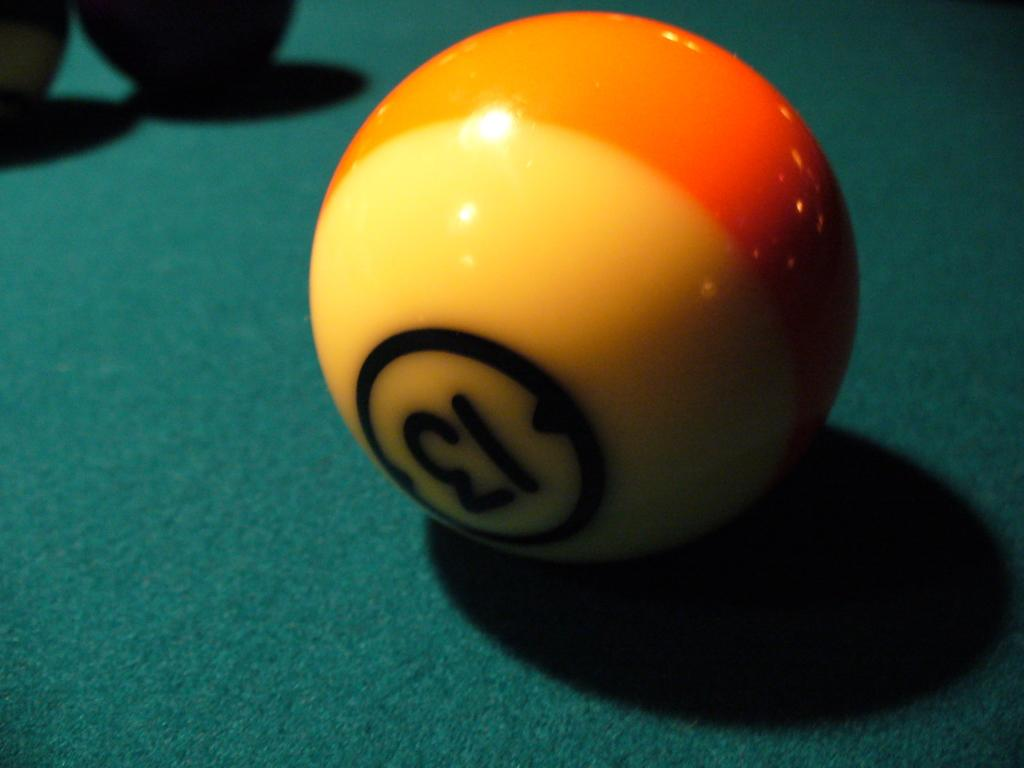What is the main object in the image? There is a billiard board in the image. What color is the billiard board? The billiard board is green. What is on top of the billiard board? There are balls on the billiard board. What colors are some of the balls on the billiard board? Some of the balls are yellow, and some are orange. What type of seed can be seen growing near the billiard board in the image? There is no seed or plant life visible near the billiard board in the image. What sound does the billiard board make when the balls collide in the image? The image is static, so no sound can be heard or described. 